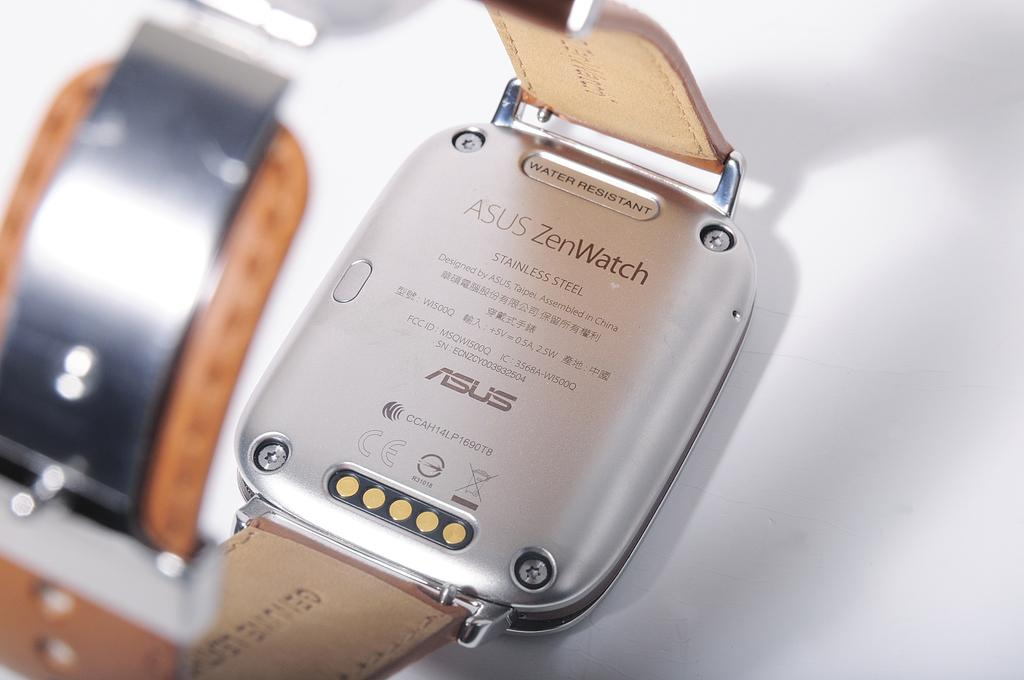<image>
Share a concise interpretation of the image provided. Person holding the back of a watch which says "Zen Watch" on it. 